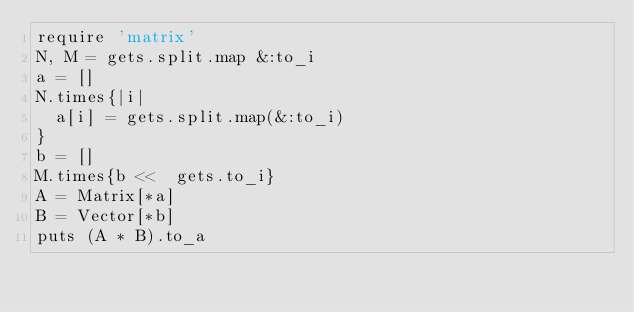<code> <loc_0><loc_0><loc_500><loc_500><_Ruby_>require 'matrix'
N, M = gets.split.map &:to_i
a = []
N.times{|i|
  a[i] = gets.split.map(&:to_i)
}
b = []
M.times{b <<  gets.to_i}
A = Matrix[*a]
B = Vector[*b]
puts (A * B).to_a</code> 